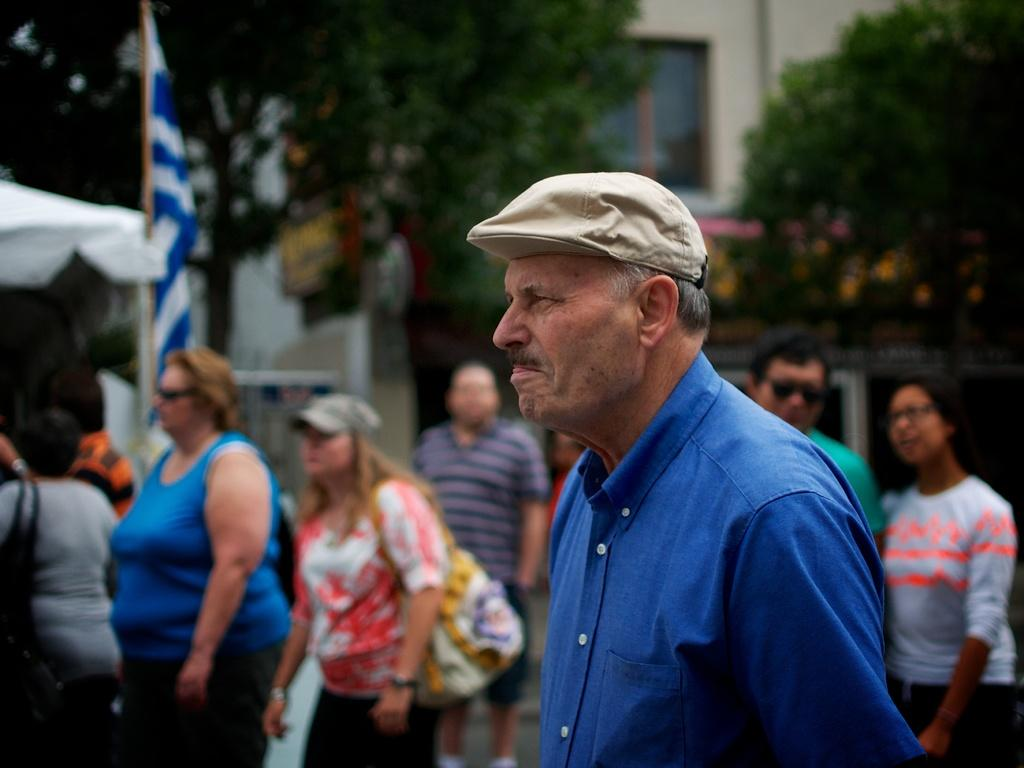Who or what can be seen in the image? There are people in the image. What is located towards the left side of the image? There is a flag towards the left side of the image. What is located towards the right side of the image? There are trees towards the right side of the image. Can you describe the vegetation in the image? There is a tree visible in the image. What type of structure can be seen in the image? There is a building with a window in the image. What are the people in the image thinking about? The image does not provide information about the thoughts of the people in the image. --- Facts: 1. There is a car in the image. 2. The car is red. 3. The car has four wheels. 4. There is a road in the image. 5. The road is paved. Absurd Topics: dance, ocean, birdhouse Conversation: What is the main subject of the image? The main subject of the image is a car. What color is the car? The car is red. How many wheels does the car have? The car has four wheels. What is the surface of the road in the image? The road is paved. Reasoning: Let's think step by step in order to produce the conversation. We start by identifying the main subject of the image, which is the car. Then, we describe specific features of the car, such as its color and the number of wheels. Finally, we describe the road's surface, which is paved, to give a sense of the road's condition. Absurd Question/Answer: Can you see any birdhouses on the road in the image? There is no birdhouse present in the image. What type of dance is being performed on the road in the image? There is no dance or dancing activity depicted in the image. --- Facts: 1. There is a person in the image. 2. The person is wearing a hat. 3. The person is holding a book. 4. There is a chair in the image. 5. The chair is made of wood. Absurd Topics: parrot, volcano, trampoline Conversation: Who or what can be seen in the image? There is a person in the image. What is the person wearing? The person is wearing a hat. What is the person holding? The person is holding a book. What is the person sitting on in the image? There is a chair in the image. What is the chair made of? The chair is made of wood. Reasoning: Let's think step by step in order to produce the conversation. We start by identifying the main subject in the image, which is the person. Then, we expand the conversation 